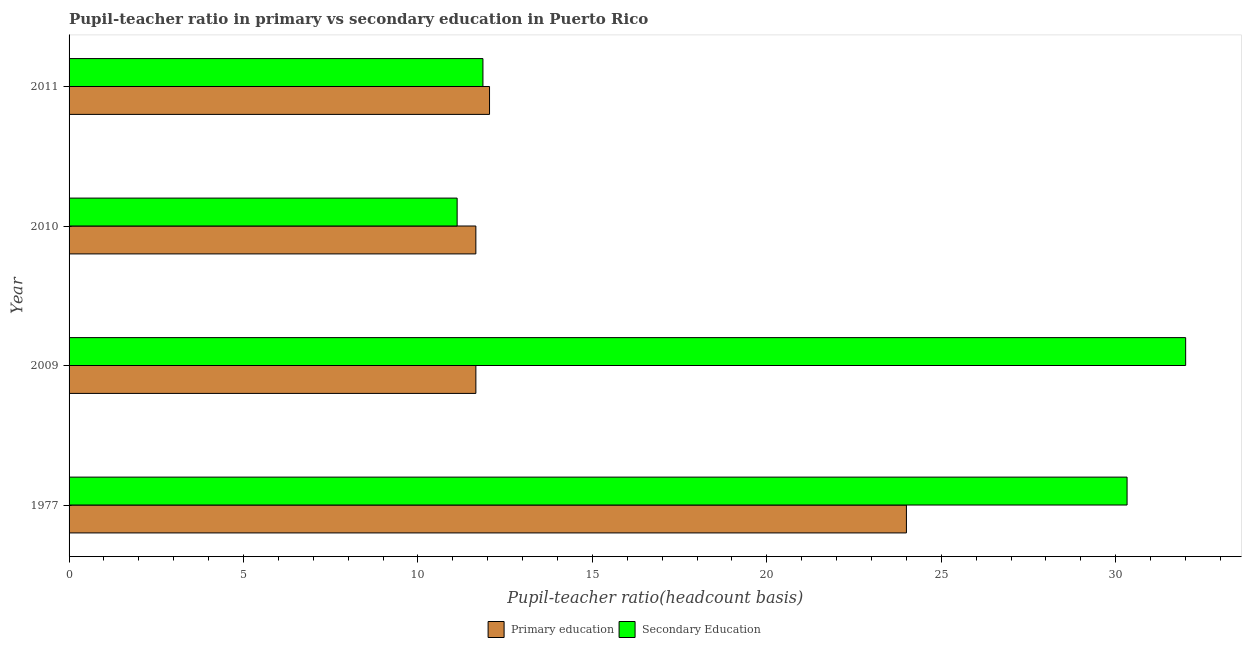How many different coloured bars are there?
Make the answer very short. 2. How many groups of bars are there?
Provide a short and direct response. 4. Are the number of bars per tick equal to the number of legend labels?
Make the answer very short. Yes. How many bars are there on the 1st tick from the top?
Your answer should be compact. 2. What is the label of the 1st group of bars from the top?
Ensure brevity in your answer.  2011. In how many cases, is the number of bars for a given year not equal to the number of legend labels?
Make the answer very short. 0. What is the pupil-teacher ratio in primary education in 2009?
Make the answer very short. 11.66. Across all years, what is the maximum pupil-teacher ratio in primary education?
Offer a very short reply. 24. Across all years, what is the minimum pupil-teacher ratio in primary education?
Offer a very short reply. 11.66. In which year was the pupil-teacher ratio in primary education minimum?
Offer a very short reply. 2010. What is the total pupil teacher ratio on secondary education in the graph?
Provide a succinct answer. 85.31. What is the difference between the pupil teacher ratio on secondary education in 1977 and that in 2009?
Provide a short and direct response. -1.68. What is the difference between the pupil-teacher ratio in primary education in 2009 and the pupil teacher ratio on secondary education in 2011?
Make the answer very short. -0.2. What is the average pupil-teacher ratio in primary education per year?
Make the answer very short. 14.84. In the year 2010, what is the difference between the pupil-teacher ratio in primary education and pupil teacher ratio on secondary education?
Give a very brief answer. 0.54. What is the ratio of the pupil teacher ratio on secondary education in 1977 to that in 2011?
Your answer should be compact. 2.56. Is the pupil-teacher ratio in primary education in 2010 less than that in 2011?
Ensure brevity in your answer.  Yes. Is the difference between the pupil teacher ratio on secondary education in 2009 and 2011 greater than the difference between the pupil-teacher ratio in primary education in 2009 and 2011?
Your answer should be very brief. Yes. What is the difference between the highest and the second highest pupil teacher ratio on secondary education?
Your answer should be very brief. 1.68. What is the difference between the highest and the lowest pupil-teacher ratio in primary education?
Your answer should be compact. 12.34. In how many years, is the pupil-teacher ratio in primary education greater than the average pupil-teacher ratio in primary education taken over all years?
Your response must be concise. 1. What does the 1st bar from the top in 1977 represents?
Ensure brevity in your answer.  Secondary Education. What does the 2nd bar from the bottom in 2009 represents?
Provide a short and direct response. Secondary Education. How many bars are there?
Ensure brevity in your answer.  8. Are all the bars in the graph horizontal?
Your response must be concise. Yes. How many years are there in the graph?
Make the answer very short. 4. Are the values on the major ticks of X-axis written in scientific E-notation?
Ensure brevity in your answer.  No. Does the graph contain any zero values?
Provide a succinct answer. No. Does the graph contain grids?
Ensure brevity in your answer.  No. Where does the legend appear in the graph?
Ensure brevity in your answer.  Bottom center. How are the legend labels stacked?
Your answer should be compact. Horizontal. What is the title of the graph?
Provide a short and direct response. Pupil-teacher ratio in primary vs secondary education in Puerto Rico. Does "Males" appear as one of the legend labels in the graph?
Provide a succinct answer. No. What is the label or title of the X-axis?
Ensure brevity in your answer.  Pupil-teacher ratio(headcount basis). What is the Pupil-teacher ratio(headcount basis) of Primary education in 1977?
Give a very brief answer. 24. What is the Pupil-teacher ratio(headcount basis) of Secondary Education in 1977?
Provide a short and direct response. 30.32. What is the Pupil-teacher ratio(headcount basis) of Primary education in 2009?
Provide a short and direct response. 11.66. What is the Pupil-teacher ratio(headcount basis) of Secondary Education in 2009?
Make the answer very short. 32. What is the Pupil-teacher ratio(headcount basis) in Primary education in 2010?
Offer a terse response. 11.66. What is the Pupil-teacher ratio(headcount basis) of Secondary Education in 2010?
Make the answer very short. 11.12. What is the Pupil-teacher ratio(headcount basis) in Primary education in 2011?
Keep it short and to the point. 12.05. What is the Pupil-teacher ratio(headcount basis) of Secondary Education in 2011?
Keep it short and to the point. 11.86. Across all years, what is the maximum Pupil-teacher ratio(headcount basis) of Primary education?
Your answer should be compact. 24. Across all years, what is the maximum Pupil-teacher ratio(headcount basis) of Secondary Education?
Ensure brevity in your answer.  32. Across all years, what is the minimum Pupil-teacher ratio(headcount basis) in Primary education?
Provide a short and direct response. 11.66. Across all years, what is the minimum Pupil-teacher ratio(headcount basis) of Secondary Education?
Offer a terse response. 11.12. What is the total Pupil-teacher ratio(headcount basis) in Primary education in the graph?
Ensure brevity in your answer.  59.37. What is the total Pupil-teacher ratio(headcount basis) in Secondary Education in the graph?
Offer a very short reply. 85.31. What is the difference between the Pupil-teacher ratio(headcount basis) of Primary education in 1977 and that in 2009?
Provide a succinct answer. 12.34. What is the difference between the Pupil-teacher ratio(headcount basis) of Secondary Education in 1977 and that in 2009?
Give a very brief answer. -1.68. What is the difference between the Pupil-teacher ratio(headcount basis) in Primary education in 1977 and that in 2010?
Offer a terse response. 12.34. What is the difference between the Pupil-teacher ratio(headcount basis) of Secondary Education in 1977 and that in 2010?
Provide a succinct answer. 19.2. What is the difference between the Pupil-teacher ratio(headcount basis) in Primary education in 1977 and that in 2011?
Give a very brief answer. 11.95. What is the difference between the Pupil-teacher ratio(headcount basis) of Secondary Education in 1977 and that in 2011?
Keep it short and to the point. 18.46. What is the difference between the Pupil-teacher ratio(headcount basis) in Secondary Education in 2009 and that in 2010?
Give a very brief answer. 20.88. What is the difference between the Pupil-teacher ratio(headcount basis) in Primary education in 2009 and that in 2011?
Your answer should be compact. -0.39. What is the difference between the Pupil-teacher ratio(headcount basis) of Secondary Education in 2009 and that in 2011?
Your answer should be very brief. 20.14. What is the difference between the Pupil-teacher ratio(headcount basis) of Primary education in 2010 and that in 2011?
Offer a terse response. -0.39. What is the difference between the Pupil-teacher ratio(headcount basis) in Secondary Education in 2010 and that in 2011?
Give a very brief answer. -0.74. What is the difference between the Pupil-teacher ratio(headcount basis) of Primary education in 1977 and the Pupil-teacher ratio(headcount basis) of Secondary Education in 2009?
Give a very brief answer. -8. What is the difference between the Pupil-teacher ratio(headcount basis) of Primary education in 1977 and the Pupil-teacher ratio(headcount basis) of Secondary Education in 2010?
Provide a succinct answer. 12.88. What is the difference between the Pupil-teacher ratio(headcount basis) in Primary education in 1977 and the Pupil-teacher ratio(headcount basis) in Secondary Education in 2011?
Keep it short and to the point. 12.14. What is the difference between the Pupil-teacher ratio(headcount basis) of Primary education in 2009 and the Pupil-teacher ratio(headcount basis) of Secondary Education in 2010?
Give a very brief answer. 0.54. What is the difference between the Pupil-teacher ratio(headcount basis) of Primary education in 2009 and the Pupil-teacher ratio(headcount basis) of Secondary Education in 2011?
Your answer should be compact. -0.2. What is the difference between the Pupil-teacher ratio(headcount basis) in Primary education in 2010 and the Pupil-teacher ratio(headcount basis) in Secondary Education in 2011?
Ensure brevity in your answer.  -0.2. What is the average Pupil-teacher ratio(headcount basis) of Primary education per year?
Your response must be concise. 14.84. What is the average Pupil-teacher ratio(headcount basis) of Secondary Education per year?
Ensure brevity in your answer.  21.33. In the year 1977, what is the difference between the Pupil-teacher ratio(headcount basis) in Primary education and Pupil-teacher ratio(headcount basis) in Secondary Education?
Offer a very short reply. -6.32. In the year 2009, what is the difference between the Pupil-teacher ratio(headcount basis) in Primary education and Pupil-teacher ratio(headcount basis) in Secondary Education?
Make the answer very short. -20.34. In the year 2010, what is the difference between the Pupil-teacher ratio(headcount basis) in Primary education and Pupil-teacher ratio(headcount basis) in Secondary Education?
Your response must be concise. 0.54. In the year 2011, what is the difference between the Pupil-teacher ratio(headcount basis) of Primary education and Pupil-teacher ratio(headcount basis) of Secondary Education?
Offer a very short reply. 0.19. What is the ratio of the Pupil-teacher ratio(headcount basis) in Primary education in 1977 to that in 2009?
Your answer should be very brief. 2.06. What is the ratio of the Pupil-teacher ratio(headcount basis) of Secondary Education in 1977 to that in 2009?
Provide a short and direct response. 0.95. What is the ratio of the Pupil-teacher ratio(headcount basis) of Primary education in 1977 to that in 2010?
Ensure brevity in your answer.  2.06. What is the ratio of the Pupil-teacher ratio(headcount basis) in Secondary Education in 1977 to that in 2010?
Provide a short and direct response. 2.73. What is the ratio of the Pupil-teacher ratio(headcount basis) of Primary education in 1977 to that in 2011?
Provide a succinct answer. 1.99. What is the ratio of the Pupil-teacher ratio(headcount basis) of Secondary Education in 1977 to that in 2011?
Offer a very short reply. 2.56. What is the ratio of the Pupil-teacher ratio(headcount basis) of Secondary Education in 2009 to that in 2010?
Ensure brevity in your answer.  2.88. What is the ratio of the Pupil-teacher ratio(headcount basis) of Primary education in 2009 to that in 2011?
Your answer should be very brief. 0.97. What is the ratio of the Pupil-teacher ratio(headcount basis) of Secondary Education in 2009 to that in 2011?
Give a very brief answer. 2.7. What is the ratio of the Pupil-teacher ratio(headcount basis) in Primary education in 2010 to that in 2011?
Offer a terse response. 0.97. What is the ratio of the Pupil-teacher ratio(headcount basis) of Secondary Education in 2010 to that in 2011?
Offer a very short reply. 0.94. What is the difference between the highest and the second highest Pupil-teacher ratio(headcount basis) in Primary education?
Keep it short and to the point. 11.95. What is the difference between the highest and the second highest Pupil-teacher ratio(headcount basis) of Secondary Education?
Ensure brevity in your answer.  1.68. What is the difference between the highest and the lowest Pupil-teacher ratio(headcount basis) in Primary education?
Your answer should be very brief. 12.34. What is the difference between the highest and the lowest Pupil-teacher ratio(headcount basis) in Secondary Education?
Provide a succinct answer. 20.88. 